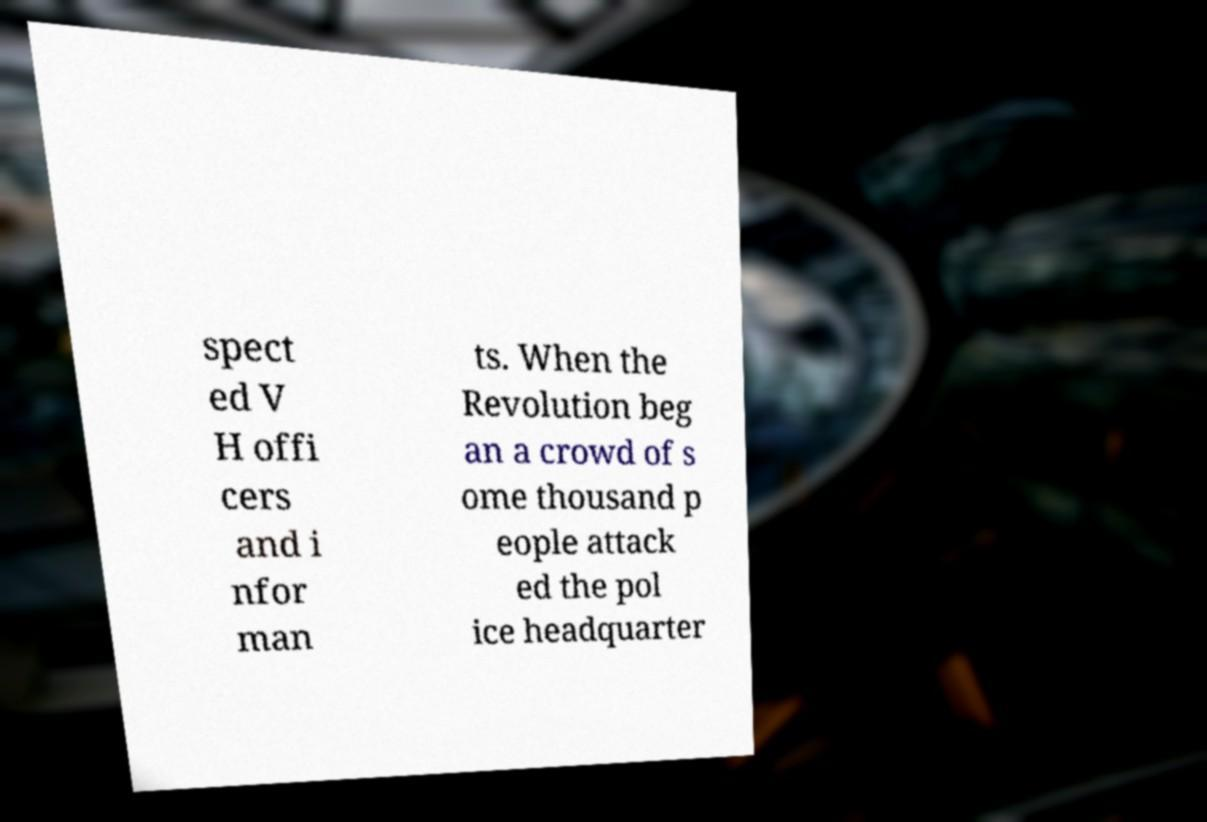Could you extract and type out the text from this image? spect ed V H offi cers and i nfor man ts. When the Revolution beg an a crowd of s ome thousand p eople attack ed the pol ice headquarter 